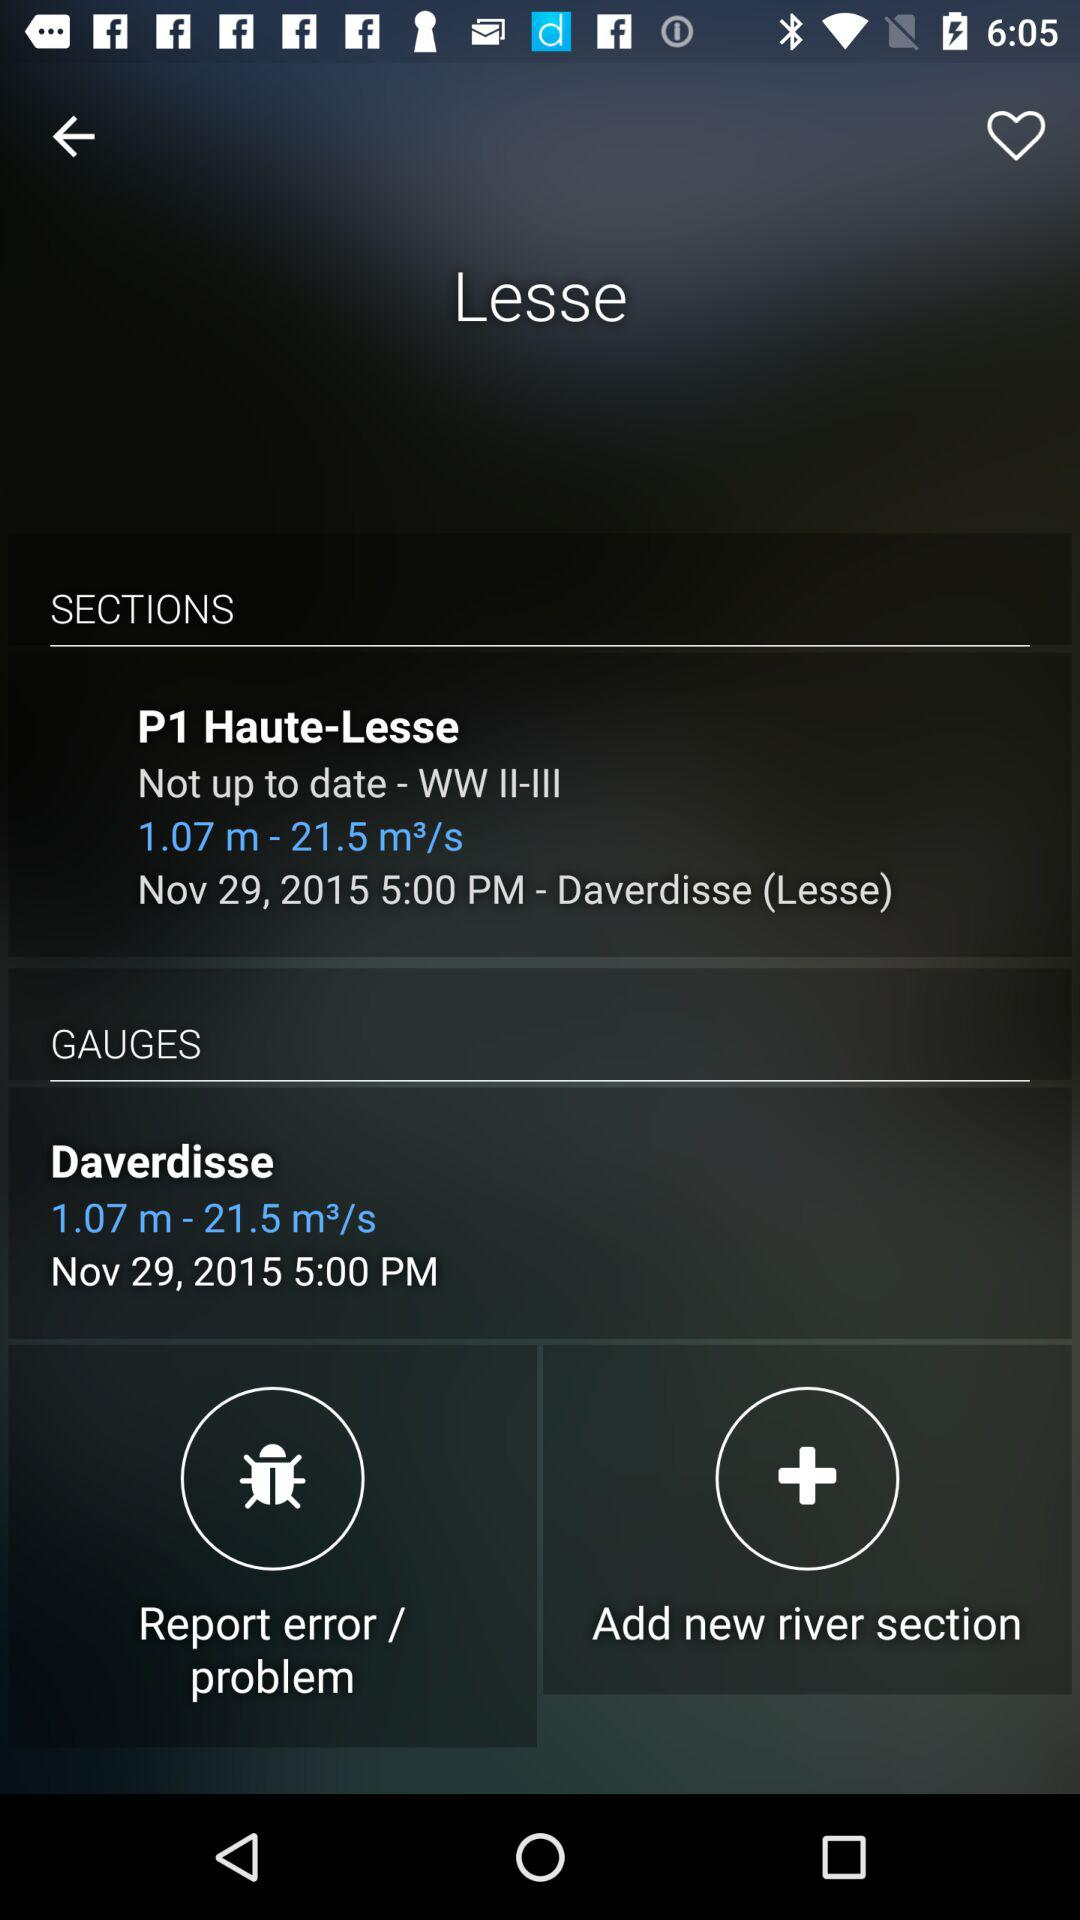How many sections are there?
Answer the question using a single word or phrase. 2 